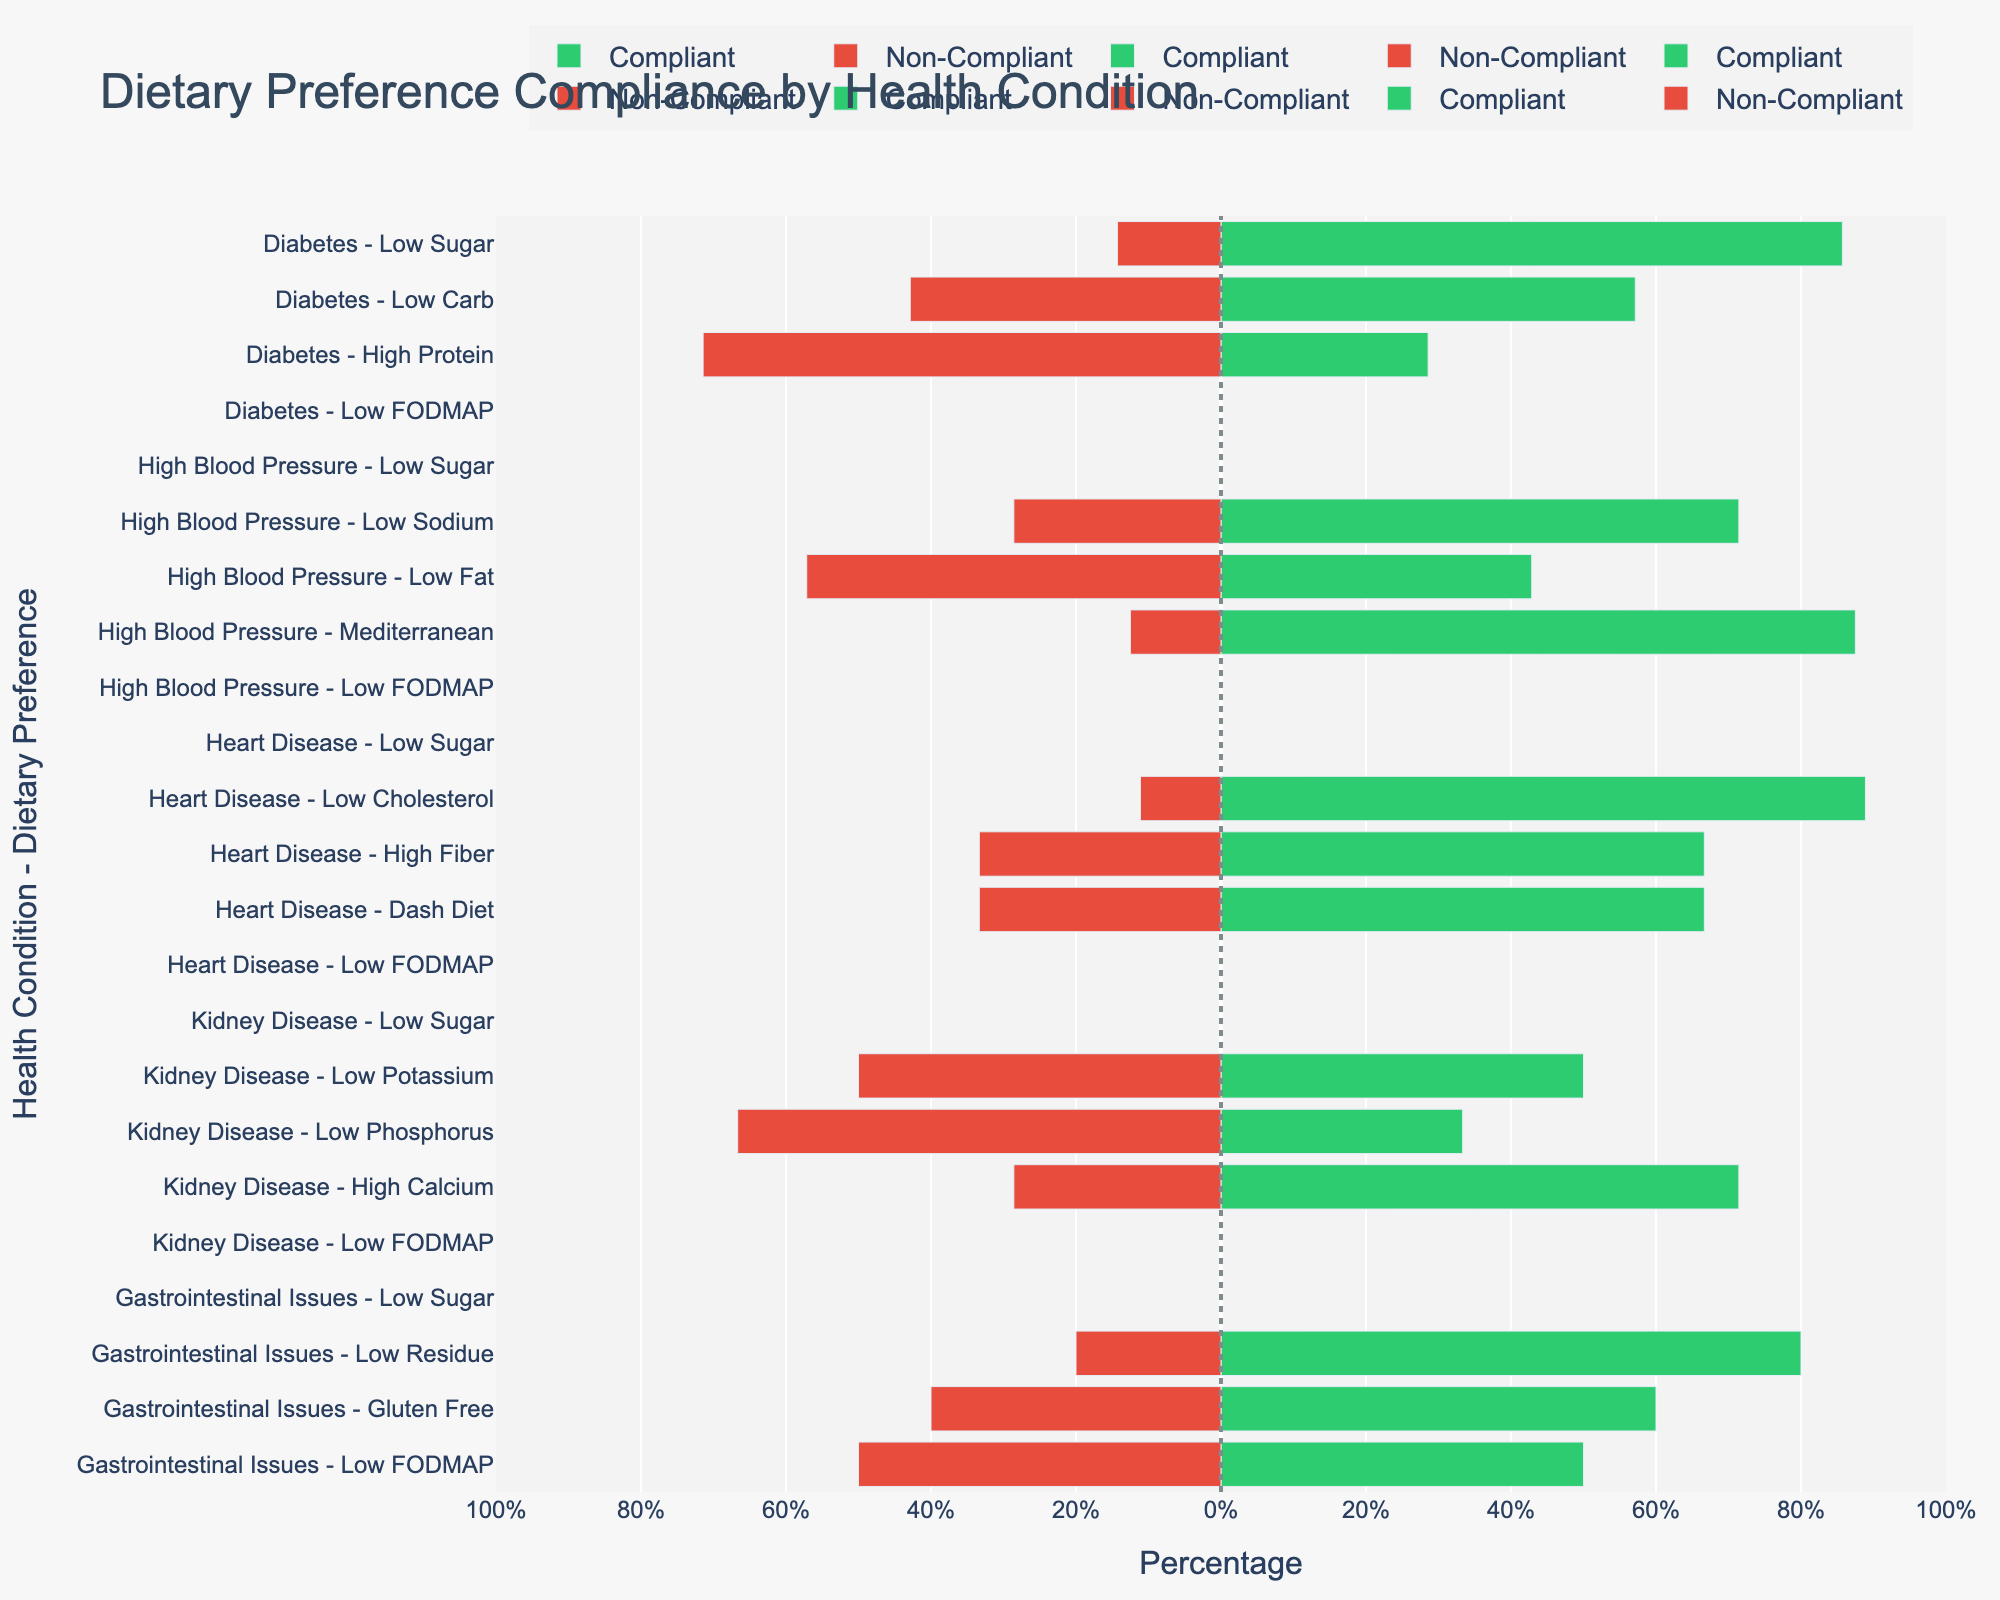What percentage of residents with High Blood Pressure on a Mediterranean diet are compliant with their dietary preference? Look at the bar corresponding to "High Blood Pressure - Mediterranean". The bar representing compliant residents (green) extends to 87.5%.
Answer: 87.5% Which condition has the highest compliance for any dietary preference? Identify the tallest green bar in the chart. The tallest green bar represents "Heart Disease - Low Cholesterol" with 88.9% compliance.
Answer: Heart Disease Are residents with diabetes more compliant with a Low Sugar diet or a Low Carb diet? Compare the green bars for "Diabetes - Low Sugar" and "Diabetes - Low Carb". "Diabetes - Low Sugar" extends to 85.7% while "Diabetes - Low Carb" extends to 57.1%.
Answer: Low Sugar For residents with Kidney Disease, which dietary preference has the least compliance? Examine the red bars associated with "Kidney Disease". The longest red bar corresponds to "Low Phosphorus" at 66.7% non-compliance.
Answer: Low Phosphorus Compare the compliance rates between Low Sodium and Low Fat diets for High Blood Pressure residents. Compare the green bars for "High Blood Pressure - Low Sodium" and "High Blood Pressure - Low Fat". "Low Sodium" has a compliance rate of 71.4% while "Low Fat" has 42.9%.
Answer: Low Sodium What’s the difference in compliance percentage between the Gluten-Free diet and Low FODMAP diet for residents with Gastrointestinal Issues? Look at the green bars for "Gastrointestinal Issues - Gluten-Free" (60%) and "Gastrointestinal Issues - Low FODMAP" (50%). The difference is calculated as 60% - 50%.
Answer: 10% Are more residents compliant with the Dash Diet for Heart Disease or Low Calcium for Kidney Disease? Compare the green bars for "Heart Disease - Dash Diet" and "Kidney Disease - Low Calcium". "Dash Diet" shows 66.7% compliance while "Low Calcium" shows 71.4%.
Answer: Low Calcium Which dietary preference shows the least compliance overall? Identify the longest red bar in the chart regardless of condition. "Diabetes - High Protein" shows the longest red bar at 71.4% non-compliance.
Answer: High Protein How does the compliance percentage for Low Residue diet in Gastrointestinal Issues compare to the compliance percentage for High Fiber diet in Heart Disease? Compare the green bars for "Gastrointestinal Issues - Low Residue" (80%) and "Heart Disease - High Fiber" (66.7%).
Answer: Low Residue is higher What is the total compliance rate for residents with High Blood Pressure (sum across all dietary preferences)? Sum the compliance rates for the three preferences under High Blood Pressure: Low Sodium (71.4%), Low Fat (42.9%), and Mediterranean (87.5%). The total is 71.4 + 42.9 + 87.5.
Answer: 201.8% 